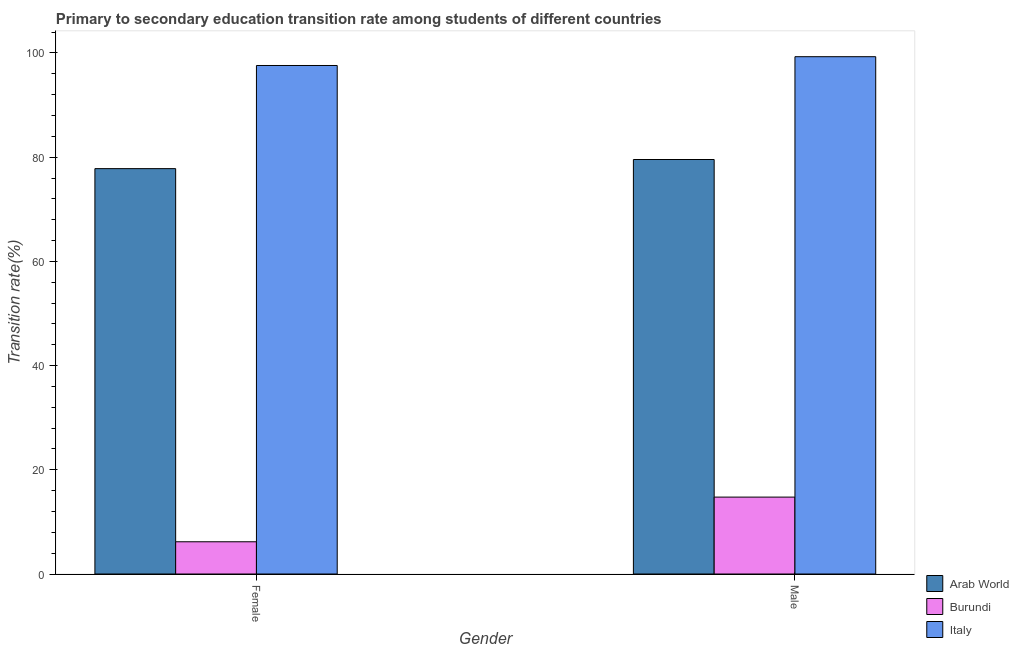What is the label of the 1st group of bars from the left?
Offer a terse response. Female. What is the transition rate among male students in Italy?
Provide a short and direct response. 99.29. Across all countries, what is the maximum transition rate among male students?
Offer a terse response. 99.29. Across all countries, what is the minimum transition rate among female students?
Make the answer very short. 6.19. In which country was the transition rate among female students maximum?
Offer a terse response. Italy. In which country was the transition rate among male students minimum?
Offer a very short reply. Burundi. What is the total transition rate among female students in the graph?
Offer a terse response. 181.59. What is the difference between the transition rate among female students in Arab World and that in Burundi?
Ensure brevity in your answer.  71.62. What is the difference between the transition rate among male students in Arab World and the transition rate among female students in Burundi?
Offer a very short reply. 73.37. What is the average transition rate among female students per country?
Offer a very short reply. 60.53. What is the difference between the transition rate among female students and transition rate among male students in Arab World?
Offer a very short reply. -1.75. What is the ratio of the transition rate among female students in Burundi to that in Arab World?
Your response must be concise. 0.08. In how many countries, is the transition rate among female students greater than the average transition rate among female students taken over all countries?
Your answer should be very brief. 2. What does the 2nd bar from the right in Female represents?
Provide a short and direct response. Burundi. How many bars are there?
Give a very brief answer. 6. How many countries are there in the graph?
Provide a succinct answer. 3. What is the difference between two consecutive major ticks on the Y-axis?
Give a very brief answer. 20. Where does the legend appear in the graph?
Give a very brief answer. Bottom right. How many legend labels are there?
Keep it short and to the point. 3. What is the title of the graph?
Your answer should be compact. Primary to secondary education transition rate among students of different countries. What is the label or title of the X-axis?
Provide a succinct answer. Gender. What is the label or title of the Y-axis?
Offer a terse response. Transition rate(%). What is the Transition rate(%) in Arab World in Female?
Your answer should be compact. 77.8. What is the Transition rate(%) in Burundi in Female?
Offer a very short reply. 6.19. What is the Transition rate(%) of Italy in Female?
Provide a succinct answer. 97.6. What is the Transition rate(%) in Arab World in Male?
Provide a short and direct response. 79.55. What is the Transition rate(%) in Burundi in Male?
Offer a very short reply. 14.76. What is the Transition rate(%) in Italy in Male?
Make the answer very short. 99.29. Across all Gender, what is the maximum Transition rate(%) of Arab World?
Your answer should be very brief. 79.55. Across all Gender, what is the maximum Transition rate(%) of Burundi?
Provide a succinct answer. 14.76. Across all Gender, what is the maximum Transition rate(%) of Italy?
Your answer should be very brief. 99.29. Across all Gender, what is the minimum Transition rate(%) in Arab World?
Keep it short and to the point. 77.8. Across all Gender, what is the minimum Transition rate(%) of Burundi?
Offer a very short reply. 6.19. Across all Gender, what is the minimum Transition rate(%) of Italy?
Offer a very short reply. 97.6. What is the total Transition rate(%) in Arab World in the graph?
Provide a short and direct response. 157.36. What is the total Transition rate(%) in Burundi in the graph?
Give a very brief answer. 20.95. What is the total Transition rate(%) in Italy in the graph?
Give a very brief answer. 196.89. What is the difference between the Transition rate(%) of Arab World in Female and that in Male?
Make the answer very short. -1.75. What is the difference between the Transition rate(%) in Burundi in Female and that in Male?
Keep it short and to the point. -8.57. What is the difference between the Transition rate(%) of Italy in Female and that in Male?
Keep it short and to the point. -1.69. What is the difference between the Transition rate(%) in Arab World in Female and the Transition rate(%) in Burundi in Male?
Make the answer very short. 63.04. What is the difference between the Transition rate(%) of Arab World in Female and the Transition rate(%) of Italy in Male?
Make the answer very short. -21.48. What is the difference between the Transition rate(%) of Burundi in Female and the Transition rate(%) of Italy in Male?
Keep it short and to the point. -93.1. What is the average Transition rate(%) in Arab World per Gender?
Your response must be concise. 78.68. What is the average Transition rate(%) in Burundi per Gender?
Ensure brevity in your answer.  10.47. What is the average Transition rate(%) in Italy per Gender?
Give a very brief answer. 98.44. What is the difference between the Transition rate(%) in Arab World and Transition rate(%) in Burundi in Female?
Offer a very short reply. 71.62. What is the difference between the Transition rate(%) of Arab World and Transition rate(%) of Italy in Female?
Offer a terse response. -19.8. What is the difference between the Transition rate(%) in Burundi and Transition rate(%) in Italy in Female?
Your answer should be compact. -91.41. What is the difference between the Transition rate(%) of Arab World and Transition rate(%) of Burundi in Male?
Provide a short and direct response. 64.79. What is the difference between the Transition rate(%) of Arab World and Transition rate(%) of Italy in Male?
Offer a terse response. -19.74. What is the difference between the Transition rate(%) in Burundi and Transition rate(%) in Italy in Male?
Provide a succinct answer. -84.53. What is the ratio of the Transition rate(%) of Burundi in Female to that in Male?
Keep it short and to the point. 0.42. What is the ratio of the Transition rate(%) in Italy in Female to that in Male?
Provide a short and direct response. 0.98. What is the difference between the highest and the second highest Transition rate(%) in Arab World?
Offer a terse response. 1.75. What is the difference between the highest and the second highest Transition rate(%) in Burundi?
Provide a short and direct response. 8.57. What is the difference between the highest and the second highest Transition rate(%) of Italy?
Your answer should be very brief. 1.69. What is the difference between the highest and the lowest Transition rate(%) of Arab World?
Keep it short and to the point. 1.75. What is the difference between the highest and the lowest Transition rate(%) of Burundi?
Make the answer very short. 8.57. What is the difference between the highest and the lowest Transition rate(%) in Italy?
Your answer should be very brief. 1.69. 